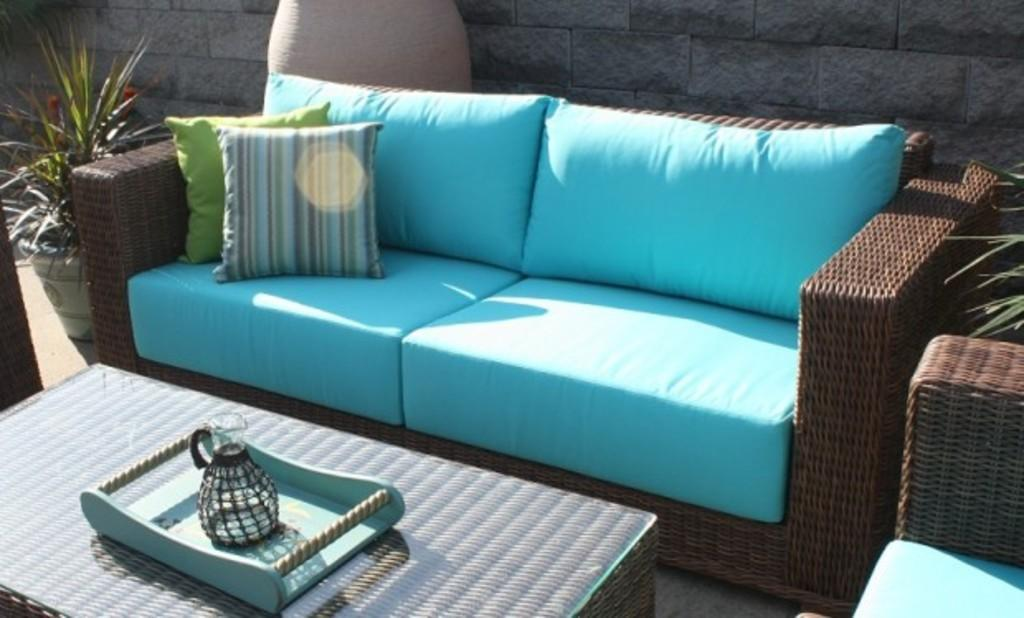What piece of furniture is present in the image? There is a table in the image. What is placed on the table? There is a tray on the table. What is on the tray? There is a jug on the tray. What type of seating is in the image? There is a sofa in the image. What is on the sofa? There are cushions on the sofa. What type of greenery is in the image? There is a plant in the image. What type of songs can be heard coming from the plant in the image? There are no songs coming from the plant in the image; it is a plant and does not produce sound. 